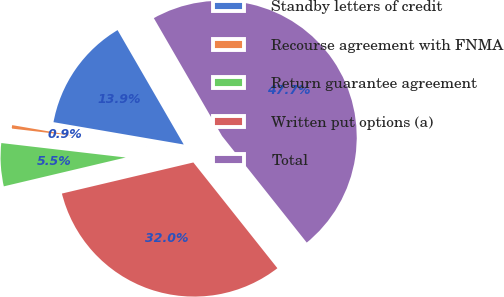Convert chart. <chart><loc_0><loc_0><loc_500><loc_500><pie_chart><fcel>Standby letters of credit<fcel>Recourse agreement with FNMA<fcel>Return guarantee agreement<fcel>Written put options (a)<fcel>Total<nl><fcel>13.95%<fcel>0.86%<fcel>5.54%<fcel>31.99%<fcel>47.66%<nl></chart> 